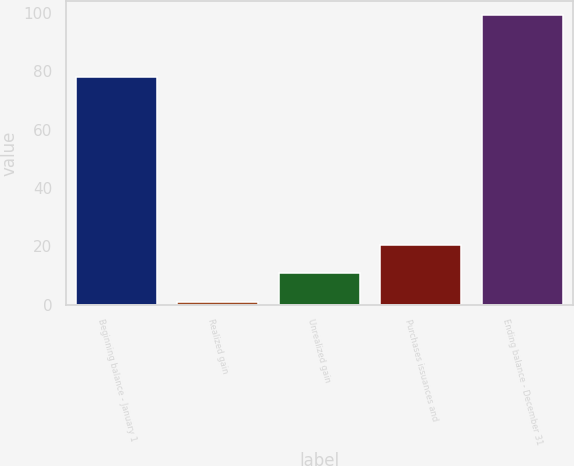Convert chart to OTSL. <chart><loc_0><loc_0><loc_500><loc_500><bar_chart><fcel>Beginning balance - January 1<fcel>Realized gain<fcel>Unrealized gain<fcel>Purchases issuances and<fcel>Ending balance - December 31<nl><fcel>78<fcel>1<fcel>10.8<fcel>20.6<fcel>99<nl></chart> 